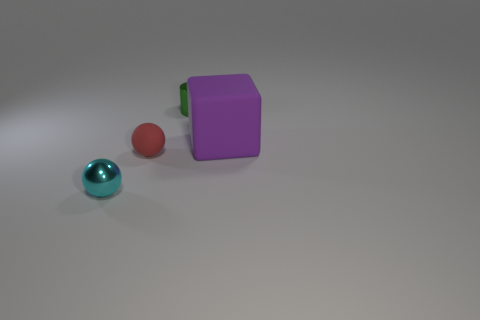What number of other objects are the same color as the big block?
Your answer should be very brief. 0. Do the object that is behind the large object and the metal thing that is in front of the green shiny cylinder have the same size?
Your answer should be compact. Yes. Is the material of the tiny red object the same as the tiny thing in front of the red object?
Keep it short and to the point. No. Is the number of green cylinders that are in front of the red thing greater than the number of cyan shiny spheres to the left of the big object?
Ensure brevity in your answer.  No. The small thing behind the rubber thing that is in front of the big object is what color?
Offer a terse response. Green. What number of blocks are small rubber things or green metal things?
Give a very brief answer. 0. What number of objects are in front of the tiny cylinder and to the left of the large block?
Ensure brevity in your answer.  2. There is a small sphere to the right of the tiny cyan sphere; what color is it?
Give a very brief answer. Red. There is a sphere that is made of the same material as the big object; what size is it?
Your answer should be very brief. Small. There is a small cyan ball in front of the purple cube; how many cyan metal objects are to the right of it?
Ensure brevity in your answer.  0. 